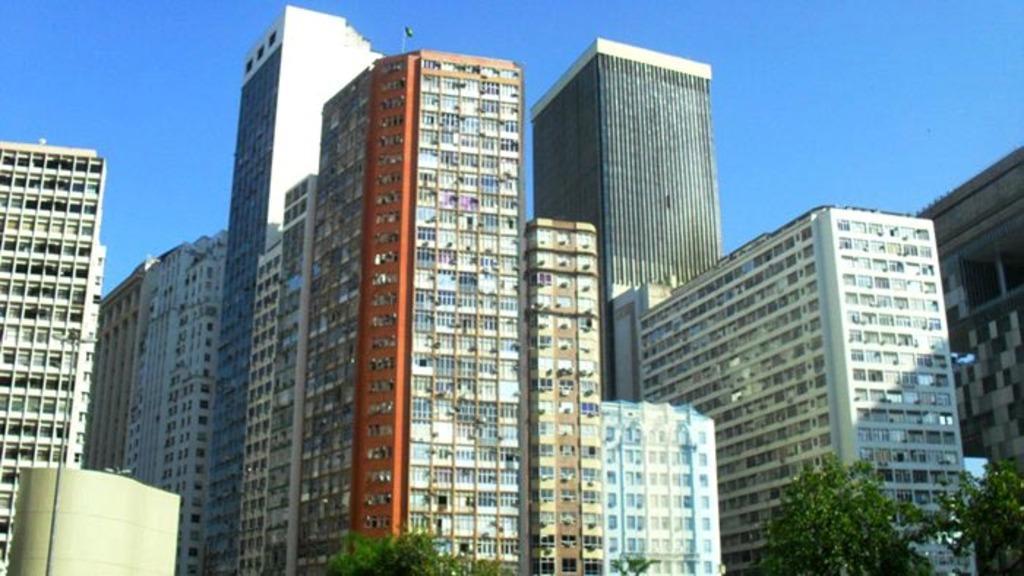Describe this image in one or two sentences. These are buildings and trees, this is sky. 